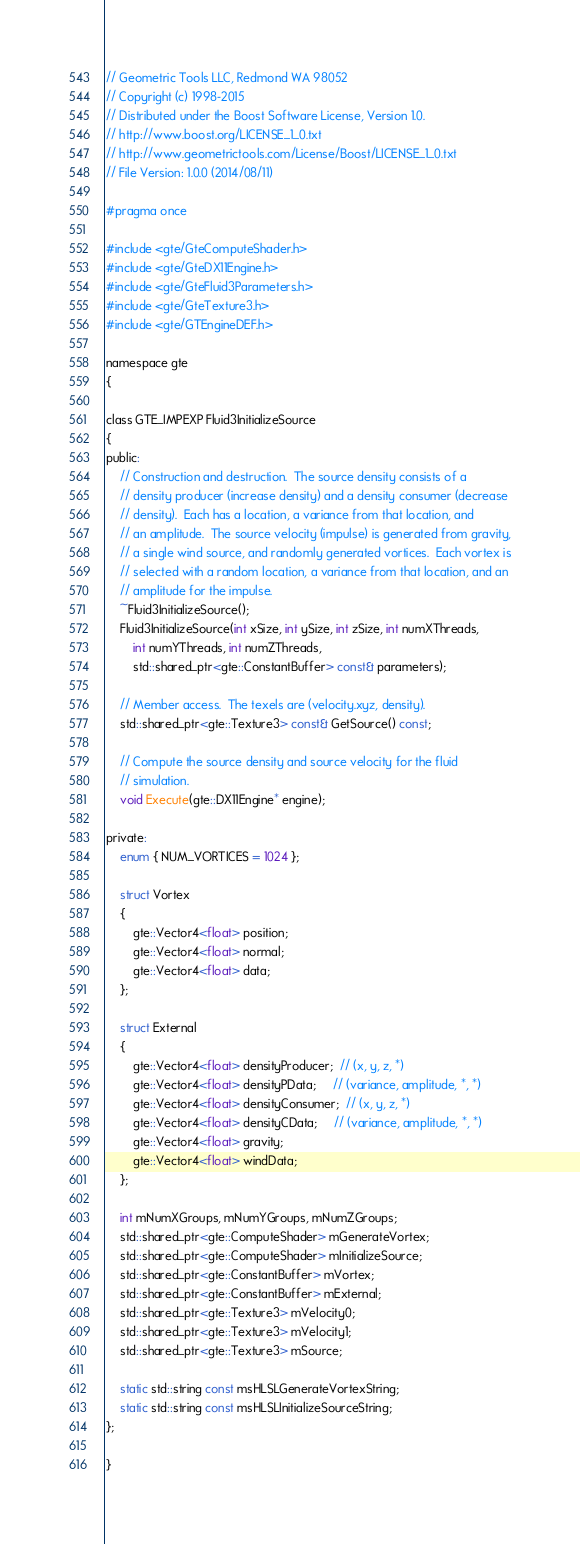<code> <loc_0><loc_0><loc_500><loc_500><_C_>// Geometric Tools LLC, Redmond WA 98052
// Copyright (c) 1998-2015
// Distributed under the Boost Software License, Version 1.0.
// http://www.boost.org/LICENSE_1_0.txt
// http://www.geometrictools.com/License/Boost/LICENSE_1_0.txt
// File Version: 1.0.0 (2014/08/11)

#pragma once

#include <gte/GteComputeShader.h>
#include <gte/GteDX11Engine.h>
#include <gte/GteFluid3Parameters.h>
#include <gte/GteTexture3.h>
#include <gte/GTEngineDEF.h>

namespace gte
{

class GTE_IMPEXP Fluid3InitializeSource
{
public:
    // Construction and destruction.  The source density consists of a
    // density producer (increase density) and a density consumer (decrease
    // density).  Each has a location, a variance from that location, and
    // an amplitude.  The source velocity (impulse) is generated from gravity,
    // a single wind source, and randomly generated vortices.  Each vortex is
    // selected with a random location, a variance from that location, and an
    // amplitude for the impulse.
    ~Fluid3InitializeSource();
    Fluid3InitializeSource(int xSize, int ySize, int zSize, int numXThreads,
        int numYThreads, int numZThreads,
        std::shared_ptr<gte::ConstantBuffer> const& parameters);

    // Member access.  The texels are (velocity.xyz, density).
    std::shared_ptr<gte::Texture3> const& GetSource() const;

    // Compute the source density and source velocity for the fluid
    // simulation.
    void Execute(gte::DX11Engine* engine);

private:
    enum { NUM_VORTICES = 1024 };

    struct Vortex
    {
        gte::Vector4<float> position;
        gte::Vector4<float> normal;
        gte::Vector4<float> data;
    };

    struct External
    {
        gte::Vector4<float> densityProducer;  // (x, y, z, *)
        gte::Vector4<float> densityPData;     // (variance, amplitude, *, *)
        gte::Vector4<float> densityConsumer;  // (x, y, z, *)
        gte::Vector4<float> densityCData;     // (variance, amplitude, *, *)
        gte::Vector4<float> gravity;
        gte::Vector4<float> windData;
    };

    int mNumXGroups, mNumYGroups, mNumZGroups;
    std::shared_ptr<gte::ComputeShader> mGenerateVortex;
    std::shared_ptr<gte::ComputeShader> mInitializeSource;
    std::shared_ptr<gte::ConstantBuffer> mVortex;
    std::shared_ptr<gte::ConstantBuffer> mExternal;
    std::shared_ptr<gte::Texture3> mVelocity0;
    std::shared_ptr<gte::Texture3> mVelocity1;
    std::shared_ptr<gte::Texture3> mSource;

    static std::string const msHLSLGenerateVortexString;
    static std::string const msHLSLInitializeSourceString;
};

}
</code> 